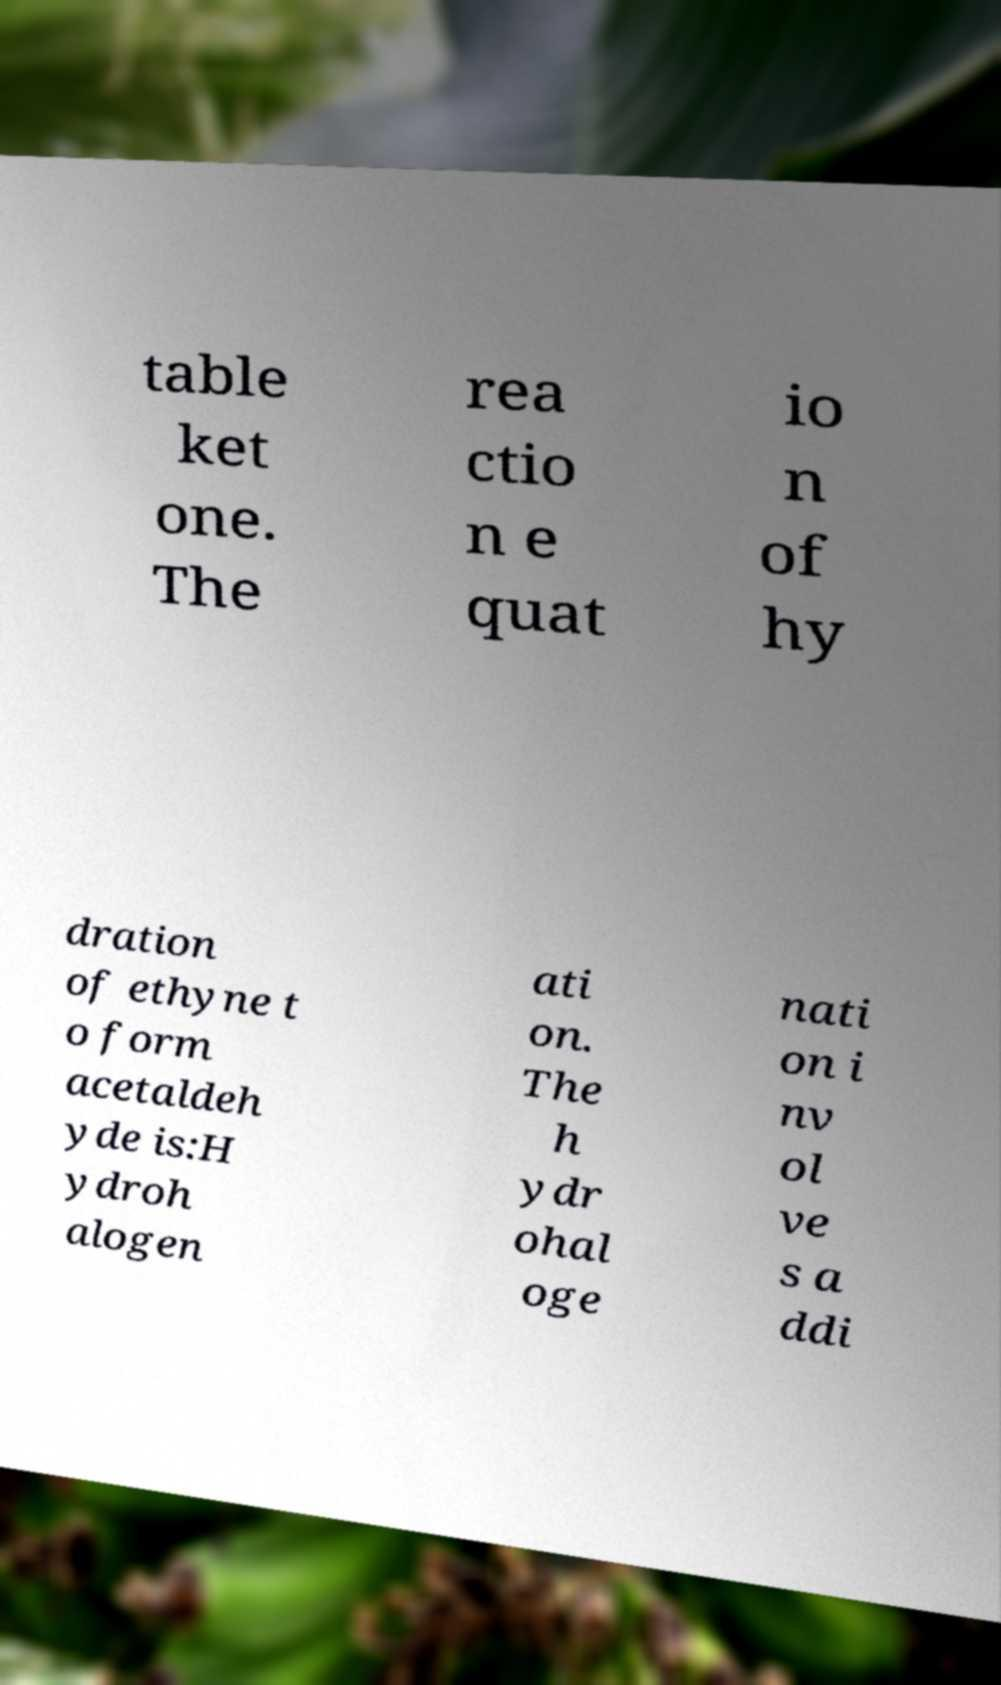Could you extract and type out the text from this image? table ket one. The rea ctio n e quat io n of hy dration of ethyne t o form acetaldeh yde is:H ydroh alogen ati on. The h ydr ohal oge nati on i nv ol ve s a ddi 